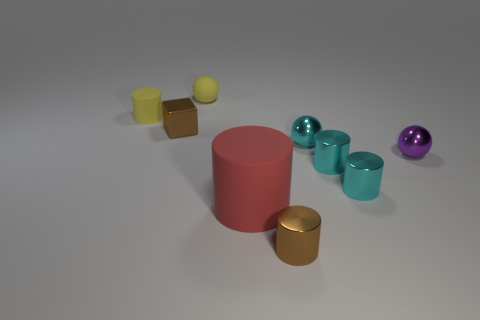Subtract 1 cylinders. How many cylinders are left? 4 Subtract all red cylinders. How many cylinders are left? 4 Subtract all yellow cylinders. How many cylinders are left? 4 Subtract all blue cylinders. Subtract all red balls. How many cylinders are left? 5 Add 1 cubes. How many objects exist? 10 Subtract all blocks. How many objects are left? 8 Subtract all brown objects. Subtract all rubber spheres. How many objects are left? 6 Add 4 purple things. How many purple things are left? 5 Add 4 tiny cyan cylinders. How many tiny cyan cylinders exist? 6 Subtract 0 gray cylinders. How many objects are left? 9 